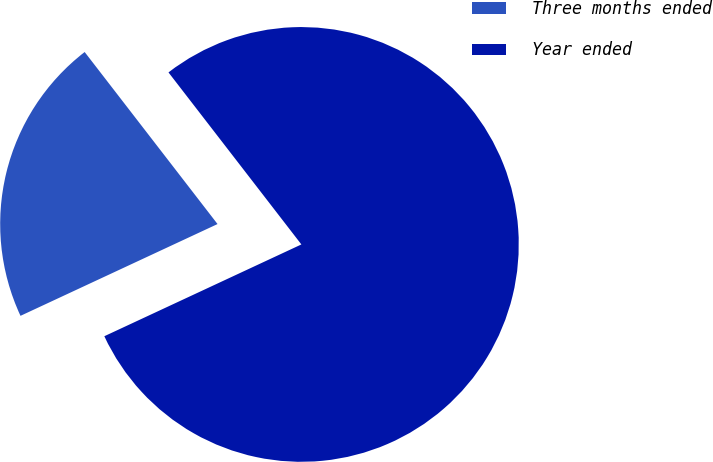<chart> <loc_0><loc_0><loc_500><loc_500><pie_chart><fcel>Three months ended<fcel>Year ended<nl><fcel>21.47%<fcel>78.53%<nl></chart> 